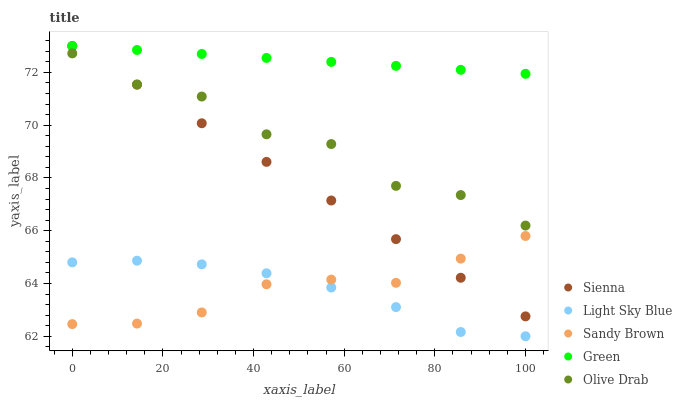Does Light Sky Blue have the minimum area under the curve?
Answer yes or no. Yes. Does Green have the maximum area under the curve?
Answer yes or no. Yes. Does Green have the minimum area under the curve?
Answer yes or no. No. Does Light Sky Blue have the maximum area under the curve?
Answer yes or no. No. Is Green the smoothest?
Answer yes or no. Yes. Is Olive Drab the roughest?
Answer yes or no. Yes. Is Light Sky Blue the smoothest?
Answer yes or no. No. Is Light Sky Blue the roughest?
Answer yes or no. No. Does Light Sky Blue have the lowest value?
Answer yes or no. Yes. Does Green have the lowest value?
Answer yes or no. No. Does Green have the highest value?
Answer yes or no. Yes. Does Light Sky Blue have the highest value?
Answer yes or no. No. Is Light Sky Blue less than Sienna?
Answer yes or no. Yes. Is Olive Drab greater than Light Sky Blue?
Answer yes or no. Yes. Does Sandy Brown intersect Light Sky Blue?
Answer yes or no. Yes. Is Sandy Brown less than Light Sky Blue?
Answer yes or no. No. Is Sandy Brown greater than Light Sky Blue?
Answer yes or no. No. Does Light Sky Blue intersect Sienna?
Answer yes or no. No. 